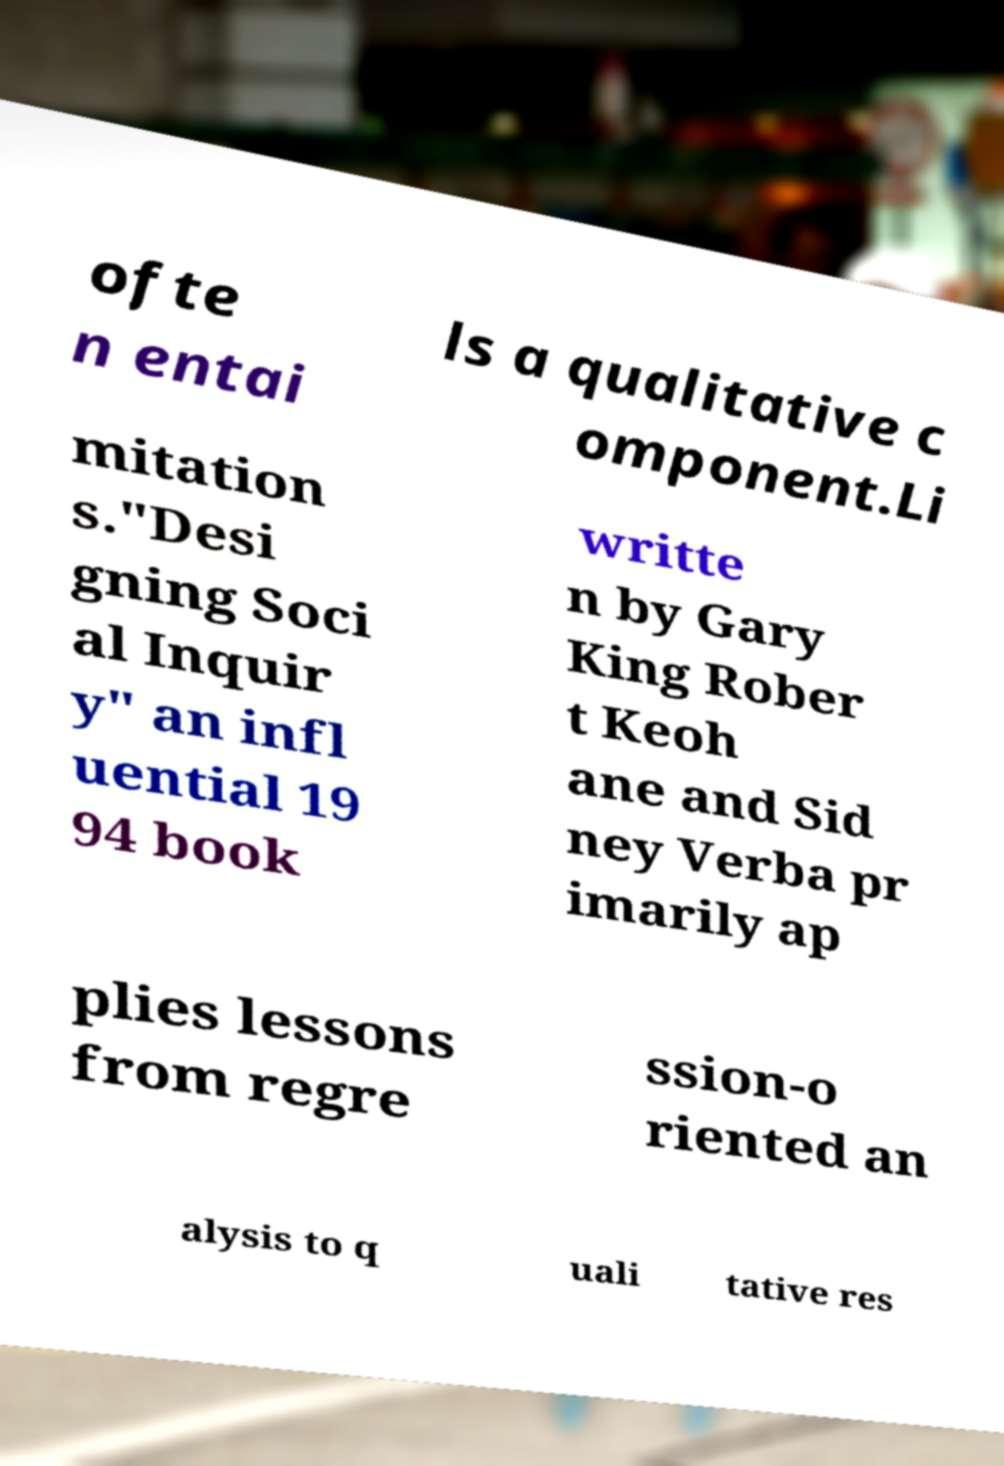For documentation purposes, I need the text within this image transcribed. Could you provide that? ofte n entai ls a qualitative c omponent.Li mitation s."Desi gning Soci al Inquir y" an infl uential 19 94 book writte n by Gary King Rober t Keoh ane and Sid ney Verba pr imarily ap plies lessons from regre ssion-o riented an alysis to q uali tative res 